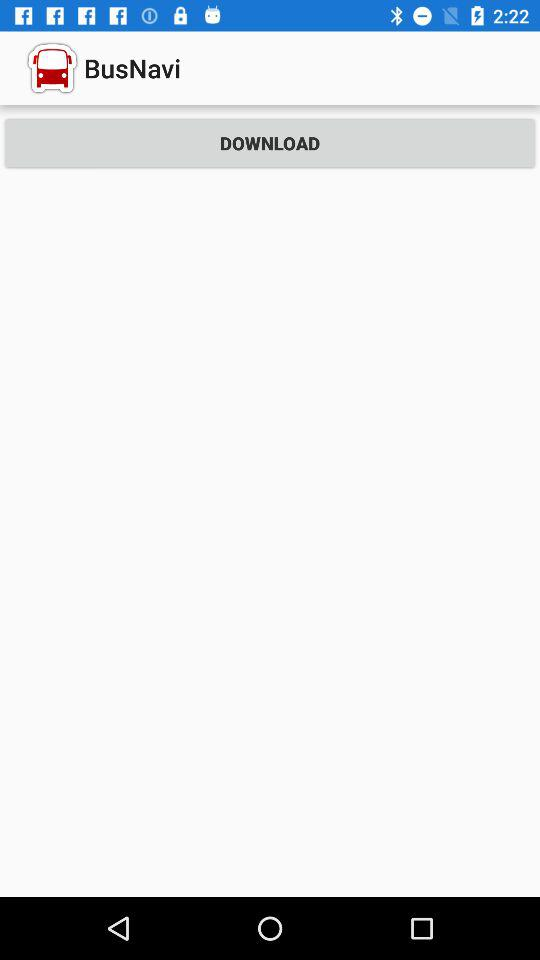What is the name of the application? The name of the application is "BusNavi". 